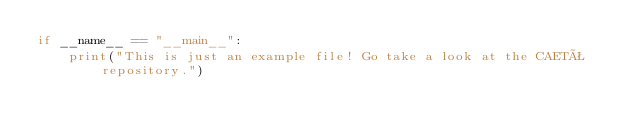<code> <loc_0><loc_0><loc_500><loc_500><_Python_>if __name__ == "__main__":
    print("This is just an example file! Go take a look at the CAETÊ repository.")</code> 